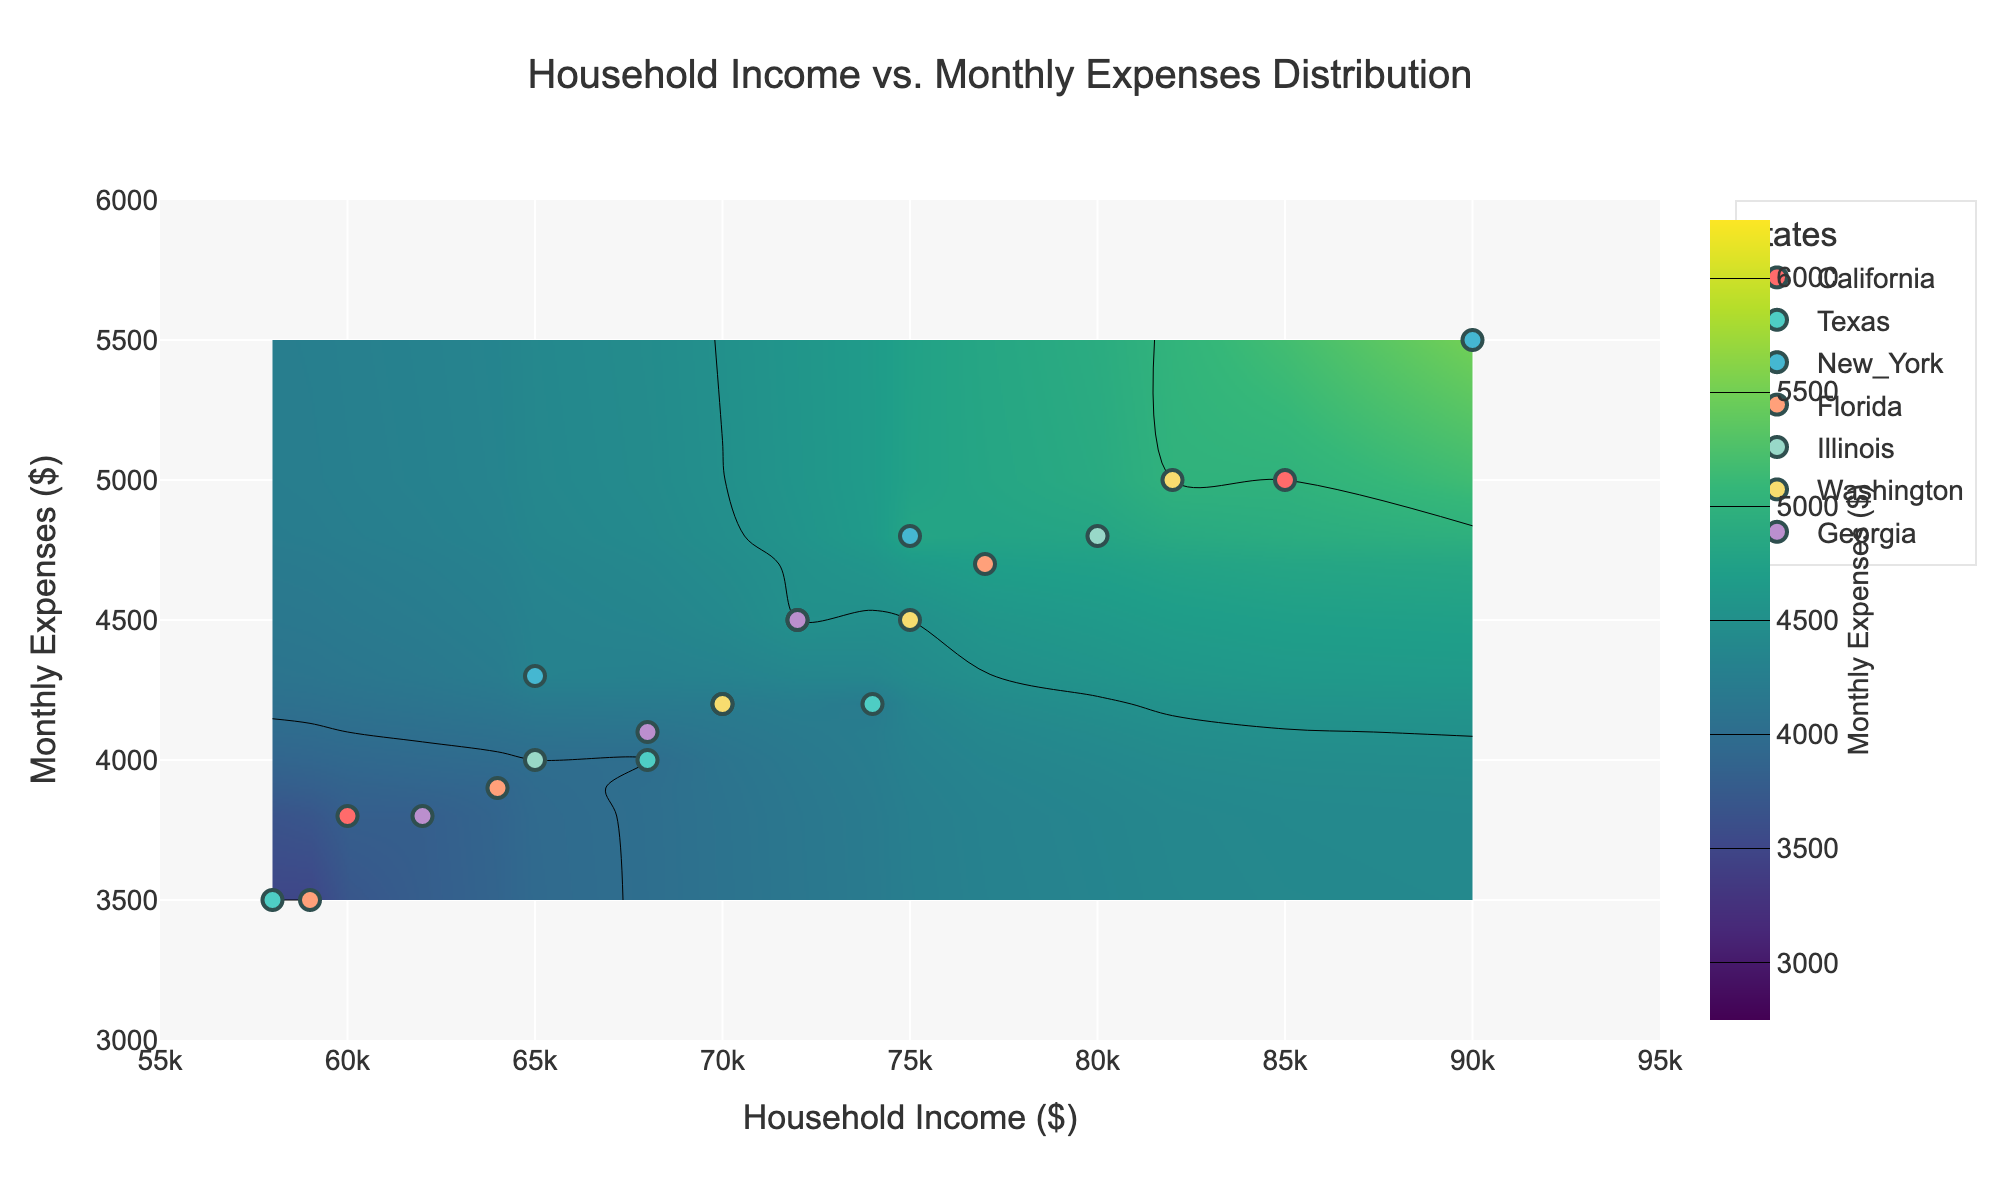What is the title of the plot? The title of the plot is located at the top center part of the figure. It provides a summary of the information represented in the plot. The title clearly states the main focus of the plot.
Answer: Household Income vs. Monthly Expenses Distribution What are the units used for the x-axis and y-axis? The units can be identified by examining the axis titles. The x-axis represents household income in dollars ($), and the y-axis represents monthly expenses in dollars ($).
Answer: Dollars Which state has the highest data point on the y-axis? To find the highest data point on the y-axis, look for the highest vertical position in the scatter plot and identify which state it belongs to. In this plot, New York has the highest data point at around $5,500.
Answer: New York How many income intervals are used in the x-axis? By observing the x-axis and counting the number of tick marks or intervals shown, you can determine the number of income intervals. The x-axis ranges from $55,000 to $95,000 with a tick every $5,000.
Answer: 8 What states have data points in the $60,000 to $70,000 income range? By focusing on the range $60,000 to $70,000 on the x-axis, you can see which states' data points fall within this range. The states are California, Texas, New York, Florida, Illinois, and Georgia.
Answer: California, Texas, New York, Florida, Illinois, Georgia What is the color range indicating the monthly expenses on the contour plot? The color range, or colorscale, used in the contour plot varies to represent different ranges of monthly expenses. By observing the colorbar, we can see it ranges from lower colors like green to higher colors like purple, indicating expenses from $3,000 to $6,000.
Answer: Green to purple Comparing California and Texas, which state has higher monthly expenses for household incomes around $70,000? By examining the scatter plot and focusing on households with incomes around $70,000 for both states, you will find that California generally has higher monthly expenses compared to Texas.
Answer: California What's the average monthly expense for households in New York based on the plot? To compute the average, locate the data points for New York on the scatter plot, sum their y-values (monthly expenses), and divide by the number of points. The values are $5,500, $4,800, $4,300. Average is (5500 + 4800 + 4300)/3 = 4,867.
Answer: $4,867 Which state shows the widest spread in monthly expenses for the given household incomes? By observing the scatter plot, the state with data points that are spread out the most vertically indicates the widest range of monthly expenses. California shows a wider spread compared to other states.
Answer: California Does the contour plot show any patterns or trends in relation to monthly expenses as household income increases? By examining the contour lines, you can identify patterns such as whether monthly expenses generally increase, decrease, or stay the same as household income increases. The contour plot suggests that as household income increases, monthly expenses generally also increase.
Answer: Monthly expenses generally increase 